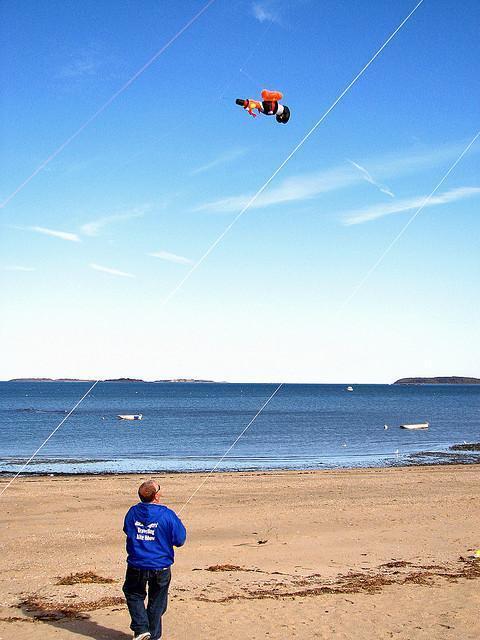How many people are visible?
Give a very brief answer. 1. 